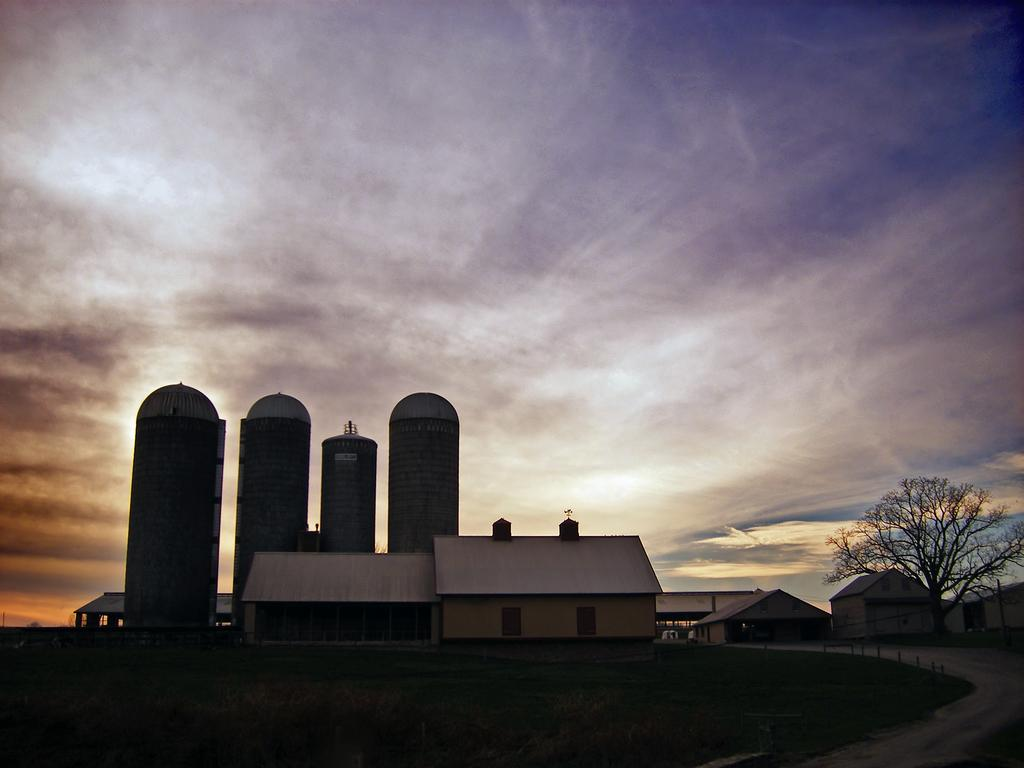What type of structure is present in the image? There is a house in the image. What is the landscape surrounding the house? The house is surrounded by grass. Are there any other natural elements in the image? Yes, there are trees in the image. How many tanks can be seen in the image? There are four tanks visible in the image. What is the color of the sky in the image? The sky appears to be dark in the image. What type of music can be heard playing from the square in the image? There is no square present in the image, and therefore no music can be heard playing from it. 